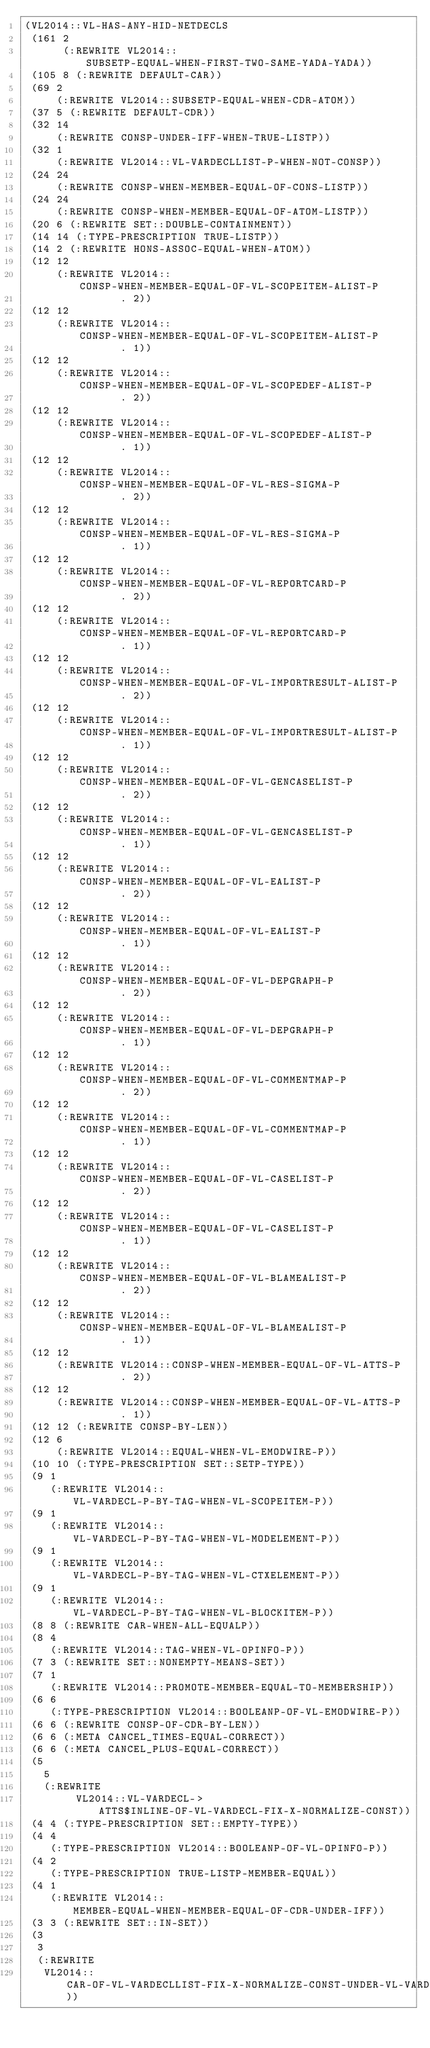Convert code to text. <code><loc_0><loc_0><loc_500><loc_500><_Lisp_>(VL2014::VL-HAS-ANY-HID-NETDECLS
 (161 2
      (:REWRITE VL2014::SUBSETP-EQUAL-WHEN-FIRST-TWO-SAME-YADA-YADA))
 (105 8 (:REWRITE DEFAULT-CAR))
 (69 2
     (:REWRITE VL2014::SUBSETP-EQUAL-WHEN-CDR-ATOM))
 (37 5 (:REWRITE DEFAULT-CDR))
 (32 14
     (:REWRITE CONSP-UNDER-IFF-WHEN-TRUE-LISTP))
 (32 1
     (:REWRITE VL2014::VL-VARDECLLIST-P-WHEN-NOT-CONSP))
 (24 24
     (:REWRITE CONSP-WHEN-MEMBER-EQUAL-OF-CONS-LISTP))
 (24 24
     (:REWRITE CONSP-WHEN-MEMBER-EQUAL-OF-ATOM-LISTP))
 (20 6 (:REWRITE SET::DOUBLE-CONTAINMENT))
 (14 14 (:TYPE-PRESCRIPTION TRUE-LISTP))
 (14 2 (:REWRITE HONS-ASSOC-EQUAL-WHEN-ATOM))
 (12 12
     (:REWRITE VL2014::CONSP-WHEN-MEMBER-EQUAL-OF-VL-SCOPEITEM-ALIST-P
               . 2))
 (12 12
     (:REWRITE VL2014::CONSP-WHEN-MEMBER-EQUAL-OF-VL-SCOPEITEM-ALIST-P
               . 1))
 (12 12
     (:REWRITE VL2014::CONSP-WHEN-MEMBER-EQUAL-OF-VL-SCOPEDEF-ALIST-P
               . 2))
 (12 12
     (:REWRITE VL2014::CONSP-WHEN-MEMBER-EQUAL-OF-VL-SCOPEDEF-ALIST-P
               . 1))
 (12 12
     (:REWRITE VL2014::CONSP-WHEN-MEMBER-EQUAL-OF-VL-RES-SIGMA-P
               . 2))
 (12 12
     (:REWRITE VL2014::CONSP-WHEN-MEMBER-EQUAL-OF-VL-RES-SIGMA-P
               . 1))
 (12 12
     (:REWRITE VL2014::CONSP-WHEN-MEMBER-EQUAL-OF-VL-REPORTCARD-P
               . 2))
 (12 12
     (:REWRITE VL2014::CONSP-WHEN-MEMBER-EQUAL-OF-VL-REPORTCARD-P
               . 1))
 (12 12
     (:REWRITE VL2014::CONSP-WHEN-MEMBER-EQUAL-OF-VL-IMPORTRESULT-ALIST-P
               . 2))
 (12 12
     (:REWRITE VL2014::CONSP-WHEN-MEMBER-EQUAL-OF-VL-IMPORTRESULT-ALIST-P
               . 1))
 (12 12
     (:REWRITE VL2014::CONSP-WHEN-MEMBER-EQUAL-OF-VL-GENCASELIST-P
               . 2))
 (12 12
     (:REWRITE VL2014::CONSP-WHEN-MEMBER-EQUAL-OF-VL-GENCASELIST-P
               . 1))
 (12 12
     (:REWRITE VL2014::CONSP-WHEN-MEMBER-EQUAL-OF-VL-EALIST-P
               . 2))
 (12 12
     (:REWRITE VL2014::CONSP-WHEN-MEMBER-EQUAL-OF-VL-EALIST-P
               . 1))
 (12 12
     (:REWRITE VL2014::CONSP-WHEN-MEMBER-EQUAL-OF-VL-DEPGRAPH-P
               . 2))
 (12 12
     (:REWRITE VL2014::CONSP-WHEN-MEMBER-EQUAL-OF-VL-DEPGRAPH-P
               . 1))
 (12 12
     (:REWRITE VL2014::CONSP-WHEN-MEMBER-EQUAL-OF-VL-COMMENTMAP-P
               . 2))
 (12 12
     (:REWRITE VL2014::CONSP-WHEN-MEMBER-EQUAL-OF-VL-COMMENTMAP-P
               . 1))
 (12 12
     (:REWRITE VL2014::CONSP-WHEN-MEMBER-EQUAL-OF-VL-CASELIST-P
               . 2))
 (12 12
     (:REWRITE VL2014::CONSP-WHEN-MEMBER-EQUAL-OF-VL-CASELIST-P
               . 1))
 (12 12
     (:REWRITE VL2014::CONSP-WHEN-MEMBER-EQUAL-OF-VL-BLAMEALIST-P
               . 2))
 (12 12
     (:REWRITE VL2014::CONSP-WHEN-MEMBER-EQUAL-OF-VL-BLAMEALIST-P
               . 1))
 (12 12
     (:REWRITE VL2014::CONSP-WHEN-MEMBER-EQUAL-OF-VL-ATTS-P
               . 2))
 (12 12
     (:REWRITE VL2014::CONSP-WHEN-MEMBER-EQUAL-OF-VL-ATTS-P
               . 1))
 (12 12 (:REWRITE CONSP-BY-LEN))
 (12 6
     (:REWRITE VL2014::EQUAL-WHEN-VL-EMODWIRE-P))
 (10 10 (:TYPE-PRESCRIPTION SET::SETP-TYPE))
 (9 1
    (:REWRITE VL2014::VL-VARDECL-P-BY-TAG-WHEN-VL-SCOPEITEM-P))
 (9 1
    (:REWRITE VL2014::VL-VARDECL-P-BY-TAG-WHEN-VL-MODELEMENT-P))
 (9 1
    (:REWRITE VL2014::VL-VARDECL-P-BY-TAG-WHEN-VL-CTXELEMENT-P))
 (9 1
    (:REWRITE VL2014::VL-VARDECL-P-BY-TAG-WHEN-VL-BLOCKITEM-P))
 (8 8 (:REWRITE CAR-WHEN-ALL-EQUALP))
 (8 4
    (:REWRITE VL2014::TAG-WHEN-VL-OPINFO-P))
 (7 3 (:REWRITE SET::NONEMPTY-MEANS-SET))
 (7 1
    (:REWRITE VL2014::PROMOTE-MEMBER-EQUAL-TO-MEMBERSHIP))
 (6 6
    (:TYPE-PRESCRIPTION VL2014::BOOLEANP-OF-VL-EMODWIRE-P))
 (6 6 (:REWRITE CONSP-OF-CDR-BY-LEN))
 (6 6 (:META CANCEL_TIMES-EQUAL-CORRECT))
 (6 6 (:META CANCEL_PLUS-EQUAL-CORRECT))
 (5
   5
   (:REWRITE
        VL2014::VL-VARDECL->ATTS$INLINE-OF-VL-VARDECL-FIX-X-NORMALIZE-CONST))
 (4 4 (:TYPE-PRESCRIPTION SET::EMPTY-TYPE))
 (4 4
    (:TYPE-PRESCRIPTION VL2014::BOOLEANP-OF-VL-OPINFO-P))
 (4 2
    (:TYPE-PRESCRIPTION TRUE-LISTP-MEMBER-EQUAL))
 (4 1
    (:REWRITE VL2014::MEMBER-EQUAL-WHEN-MEMBER-EQUAL-OF-CDR-UNDER-IFF))
 (3 3 (:REWRITE SET::IN-SET))
 (3
  3
  (:REWRITE
   VL2014::CAR-OF-VL-VARDECLLIST-FIX-X-NORMALIZE-CONST-UNDER-VL-VARDECL-EQUIV))</code> 